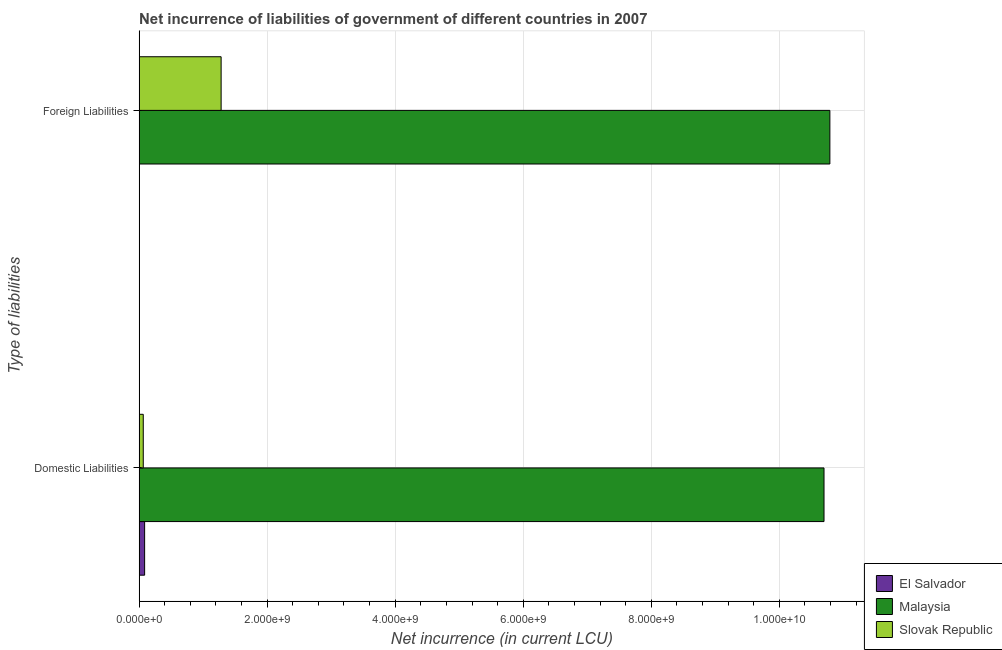How many different coloured bars are there?
Your response must be concise. 3. How many groups of bars are there?
Offer a terse response. 2. Are the number of bars per tick equal to the number of legend labels?
Provide a succinct answer. No. Are the number of bars on each tick of the Y-axis equal?
Keep it short and to the point. No. How many bars are there on the 1st tick from the bottom?
Your answer should be compact. 3. What is the label of the 2nd group of bars from the top?
Keep it short and to the point. Domestic Liabilities. What is the net incurrence of domestic liabilities in El Salvador?
Ensure brevity in your answer.  8.63e+07. Across all countries, what is the maximum net incurrence of domestic liabilities?
Your answer should be very brief. 1.07e+1. Across all countries, what is the minimum net incurrence of domestic liabilities?
Provide a succinct answer. 6.51e+07. In which country was the net incurrence of foreign liabilities maximum?
Make the answer very short. Malaysia. What is the total net incurrence of foreign liabilities in the graph?
Provide a short and direct response. 1.21e+1. What is the difference between the net incurrence of domestic liabilities in Malaysia and that in Slovak Republic?
Keep it short and to the point. 1.06e+1. What is the difference between the net incurrence of domestic liabilities in El Salvador and the net incurrence of foreign liabilities in Slovak Republic?
Your response must be concise. -1.19e+09. What is the average net incurrence of domestic liabilities per country?
Your answer should be very brief. 3.62e+09. What is the difference between the net incurrence of foreign liabilities and net incurrence of domestic liabilities in Malaysia?
Keep it short and to the point. 9.14e+07. What is the ratio of the net incurrence of foreign liabilities in Slovak Republic to that in Malaysia?
Ensure brevity in your answer.  0.12. Is the net incurrence of foreign liabilities in Malaysia less than that in Slovak Republic?
Provide a short and direct response. No. In how many countries, is the net incurrence of domestic liabilities greater than the average net incurrence of domestic liabilities taken over all countries?
Keep it short and to the point. 1. How many bars are there?
Your answer should be compact. 5. Are all the bars in the graph horizontal?
Your answer should be compact. Yes. How many countries are there in the graph?
Ensure brevity in your answer.  3. Are the values on the major ticks of X-axis written in scientific E-notation?
Offer a terse response. Yes. Does the graph contain any zero values?
Your answer should be very brief. Yes. How many legend labels are there?
Offer a very short reply. 3. What is the title of the graph?
Keep it short and to the point. Net incurrence of liabilities of government of different countries in 2007. What is the label or title of the X-axis?
Provide a short and direct response. Net incurrence (in current LCU). What is the label or title of the Y-axis?
Make the answer very short. Type of liabilities. What is the Net incurrence (in current LCU) in El Salvador in Domestic Liabilities?
Give a very brief answer. 8.63e+07. What is the Net incurrence (in current LCU) in Malaysia in Domestic Liabilities?
Your answer should be compact. 1.07e+1. What is the Net incurrence (in current LCU) in Slovak Republic in Domestic Liabilities?
Your answer should be very brief. 6.51e+07. What is the Net incurrence (in current LCU) in El Salvador in Foreign Liabilities?
Give a very brief answer. 0. What is the Net incurrence (in current LCU) in Malaysia in Foreign Liabilities?
Offer a terse response. 1.08e+1. What is the Net incurrence (in current LCU) in Slovak Republic in Foreign Liabilities?
Your answer should be compact. 1.28e+09. Across all Type of liabilities, what is the maximum Net incurrence (in current LCU) in El Salvador?
Offer a very short reply. 8.63e+07. Across all Type of liabilities, what is the maximum Net incurrence (in current LCU) in Malaysia?
Make the answer very short. 1.08e+1. Across all Type of liabilities, what is the maximum Net incurrence (in current LCU) of Slovak Republic?
Ensure brevity in your answer.  1.28e+09. Across all Type of liabilities, what is the minimum Net incurrence (in current LCU) in Malaysia?
Provide a short and direct response. 1.07e+1. Across all Type of liabilities, what is the minimum Net incurrence (in current LCU) in Slovak Republic?
Your answer should be compact. 6.51e+07. What is the total Net incurrence (in current LCU) of El Salvador in the graph?
Provide a succinct answer. 8.63e+07. What is the total Net incurrence (in current LCU) of Malaysia in the graph?
Offer a terse response. 2.15e+1. What is the total Net incurrence (in current LCU) of Slovak Republic in the graph?
Provide a short and direct response. 1.35e+09. What is the difference between the Net incurrence (in current LCU) of Malaysia in Domestic Liabilities and that in Foreign Liabilities?
Your response must be concise. -9.14e+07. What is the difference between the Net incurrence (in current LCU) of Slovak Republic in Domestic Liabilities and that in Foreign Liabilities?
Your response must be concise. -1.22e+09. What is the difference between the Net incurrence (in current LCU) in El Salvador in Domestic Liabilities and the Net incurrence (in current LCU) in Malaysia in Foreign Liabilities?
Keep it short and to the point. -1.07e+1. What is the difference between the Net incurrence (in current LCU) in El Salvador in Domestic Liabilities and the Net incurrence (in current LCU) in Slovak Republic in Foreign Liabilities?
Your response must be concise. -1.19e+09. What is the difference between the Net incurrence (in current LCU) in Malaysia in Domestic Liabilities and the Net incurrence (in current LCU) in Slovak Republic in Foreign Liabilities?
Make the answer very short. 9.42e+09. What is the average Net incurrence (in current LCU) in El Salvador per Type of liabilities?
Ensure brevity in your answer.  4.32e+07. What is the average Net incurrence (in current LCU) in Malaysia per Type of liabilities?
Make the answer very short. 1.07e+1. What is the average Net incurrence (in current LCU) in Slovak Republic per Type of liabilities?
Provide a succinct answer. 6.73e+08. What is the difference between the Net incurrence (in current LCU) in El Salvador and Net incurrence (in current LCU) in Malaysia in Domestic Liabilities?
Your answer should be very brief. -1.06e+1. What is the difference between the Net incurrence (in current LCU) in El Salvador and Net incurrence (in current LCU) in Slovak Republic in Domestic Liabilities?
Provide a short and direct response. 2.12e+07. What is the difference between the Net incurrence (in current LCU) in Malaysia and Net incurrence (in current LCU) in Slovak Republic in Domestic Liabilities?
Offer a terse response. 1.06e+1. What is the difference between the Net incurrence (in current LCU) of Malaysia and Net incurrence (in current LCU) of Slovak Republic in Foreign Liabilities?
Give a very brief answer. 9.51e+09. What is the ratio of the Net incurrence (in current LCU) in Malaysia in Domestic Liabilities to that in Foreign Liabilities?
Ensure brevity in your answer.  0.99. What is the ratio of the Net incurrence (in current LCU) in Slovak Republic in Domestic Liabilities to that in Foreign Liabilities?
Keep it short and to the point. 0.05. What is the difference between the highest and the second highest Net incurrence (in current LCU) in Malaysia?
Make the answer very short. 9.14e+07. What is the difference between the highest and the second highest Net incurrence (in current LCU) of Slovak Republic?
Provide a short and direct response. 1.22e+09. What is the difference between the highest and the lowest Net incurrence (in current LCU) of El Salvador?
Give a very brief answer. 8.63e+07. What is the difference between the highest and the lowest Net incurrence (in current LCU) in Malaysia?
Ensure brevity in your answer.  9.14e+07. What is the difference between the highest and the lowest Net incurrence (in current LCU) of Slovak Republic?
Ensure brevity in your answer.  1.22e+09. 